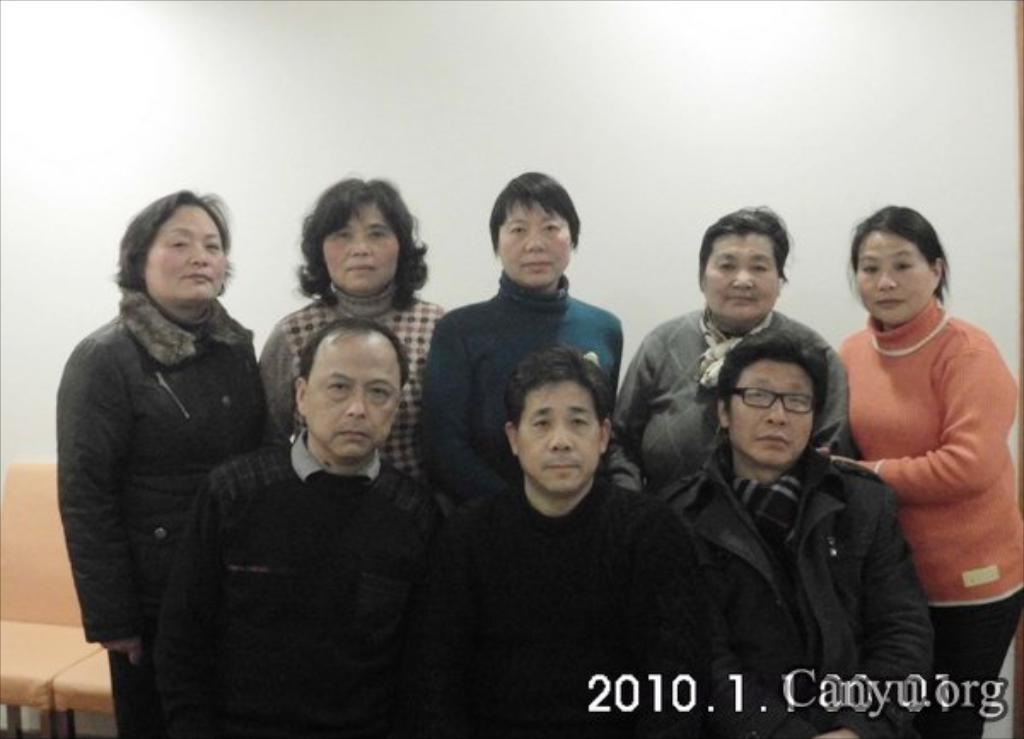How many people are in the image? There is a group of people in the image. What are the people doing in the image? The people are standing. What is located behind the people in the image? There are chairs behind the people. What can be seen in the background of the image? There is a wall visible in the image. What type of cake is being pulled by the actor in the image? There is no cake or actor present in the image. How does the actor pull the cake in the image? Since there is no cake or actor in the image, it is not possible to answer this question. 